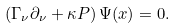Convert formula to latex. <formula><loc_0><loc_0><loc_500><loc_500>\left ( \Gamma _ { \nu } \partial _ { \nu } + \kappa P \right ) \Psi ( x ) = 0 .</formula> 